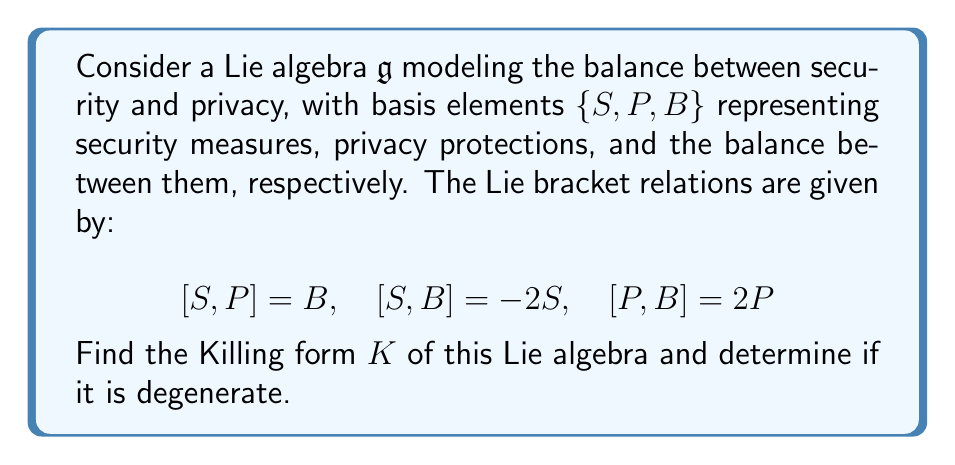Solve this math problem. To find the Killing form of the Lie algebra $\mathfrak{g}$, we follow these steps:

1) The Killing form $K(X, Y)$ is defined as $K(X, Y) = \text{tr}(\text{ad}_X \circ \text{ad}_Y)$, where $\text{ad}_X(Z) = [X, Z]$.

2) We need to compute the adjoint representations for each basis element:

   For $S$: $\text{ad}_S(S) = 0$, $\text{ad}_S(P) = B$, $\text{ad}_S(B) = -2S$
   For $P$: $\text{ad}_P(S) = -B$, $\text{ad}_P(P) = 0$, $\text{ad}_P(B) = 2P$
   For $B$: $\text{ad}_B(S) = 2S$, $\text{ad}_B(P) = -2P$, $\text{ad}_B(B) = 0$

3) We can represent these as matrices:

   $$\text{ad}_S = \begin{pmatrix} 0 & 0 & -2 \\ 0 & 0 & 0 \\ 1 & 0 & 0 \end{pmatrix}, \quad
   \text{ad}_P = \begin{pmatrix} 0 & 0 & 0 \\ 0 & 0 & 2 \\ -1 & 0 & 0 \end{pmatrix}, \quad
   \text{ad}_B = \begin{pmatrix} 2 & 0 & 0 \\ 0 & -2 & 0 \\ 0 & 0 & 0 \end{pmatrix}$$

4) Now we compute the Killing form for each pair of basis elements:

   $K(S,S) = \text{tr}(\text{ad}_S \circ \text{ad}_S) = 0$
   $K(S,P) = \text{tr}(\text{ad}_S \circ \text{ad}_P) = -2$
   $K(S,B) = \text{tr}(\text{ad}_S \circ \text{ad}_B) = 0$
   $K(P,P) = \text{tr}(\text{ad}_P \circ \text{ad}_P) = 0$
   $K(P,B) = \text{tr}(\text{ad}_P \circ \text{ad}_B) = 0$
   $K(B,B) = \text{tr}(\text{ad}_B \circ \text{ad}_B) = 8$

5) The Killing form matrix is therefore:

   $$K = \begin{pmatrix} 0 & -2 & 0 \\ -2 & 0 & 0 \\ 0 & 0 & 8 \end{pmatrix}$$

6) To determine if the Killing form is degenerate, we calculate its determinant:

   $\det(K) = 0 \cdot 8 - (-2)^2 \cdot 8 = -32 \neq 0$

   Since the determinant is non-zero, the Killing form is non-degenerate.
Answer: $K = \begin{pmatrix} 0 & -2 & 0 \\ -2 & 0 & 0 \\ 0 & 0 & 8 \end{pmatrix}$, non-degenerate 